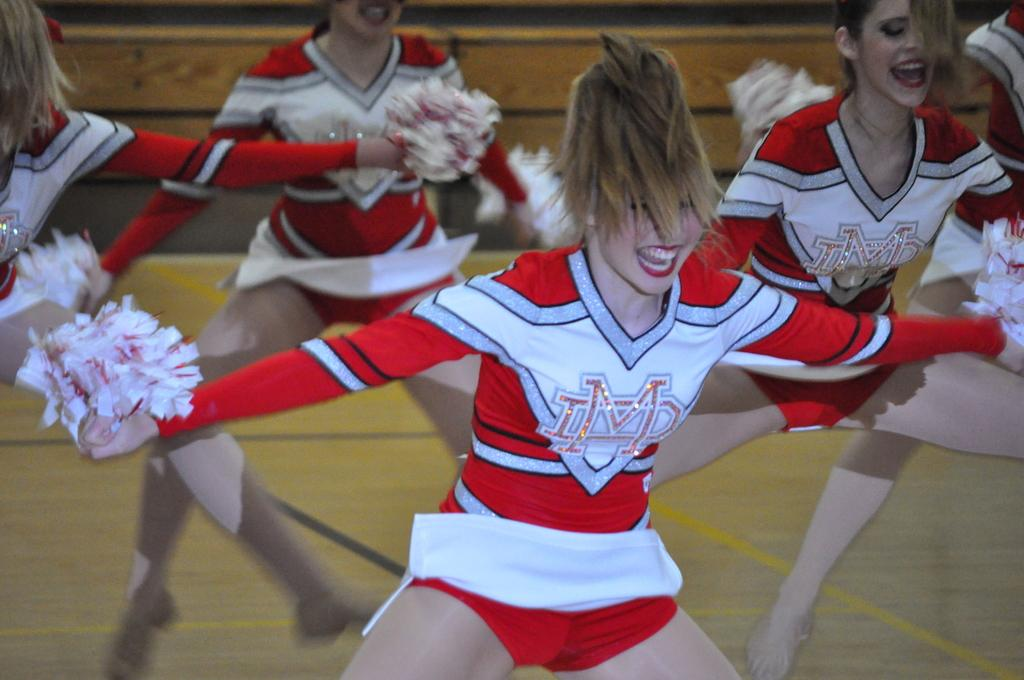<image>
Give a short and clear explanation of the subsequent image. happy cheerleaders in red and white uniforms with LMD on them do a routine 